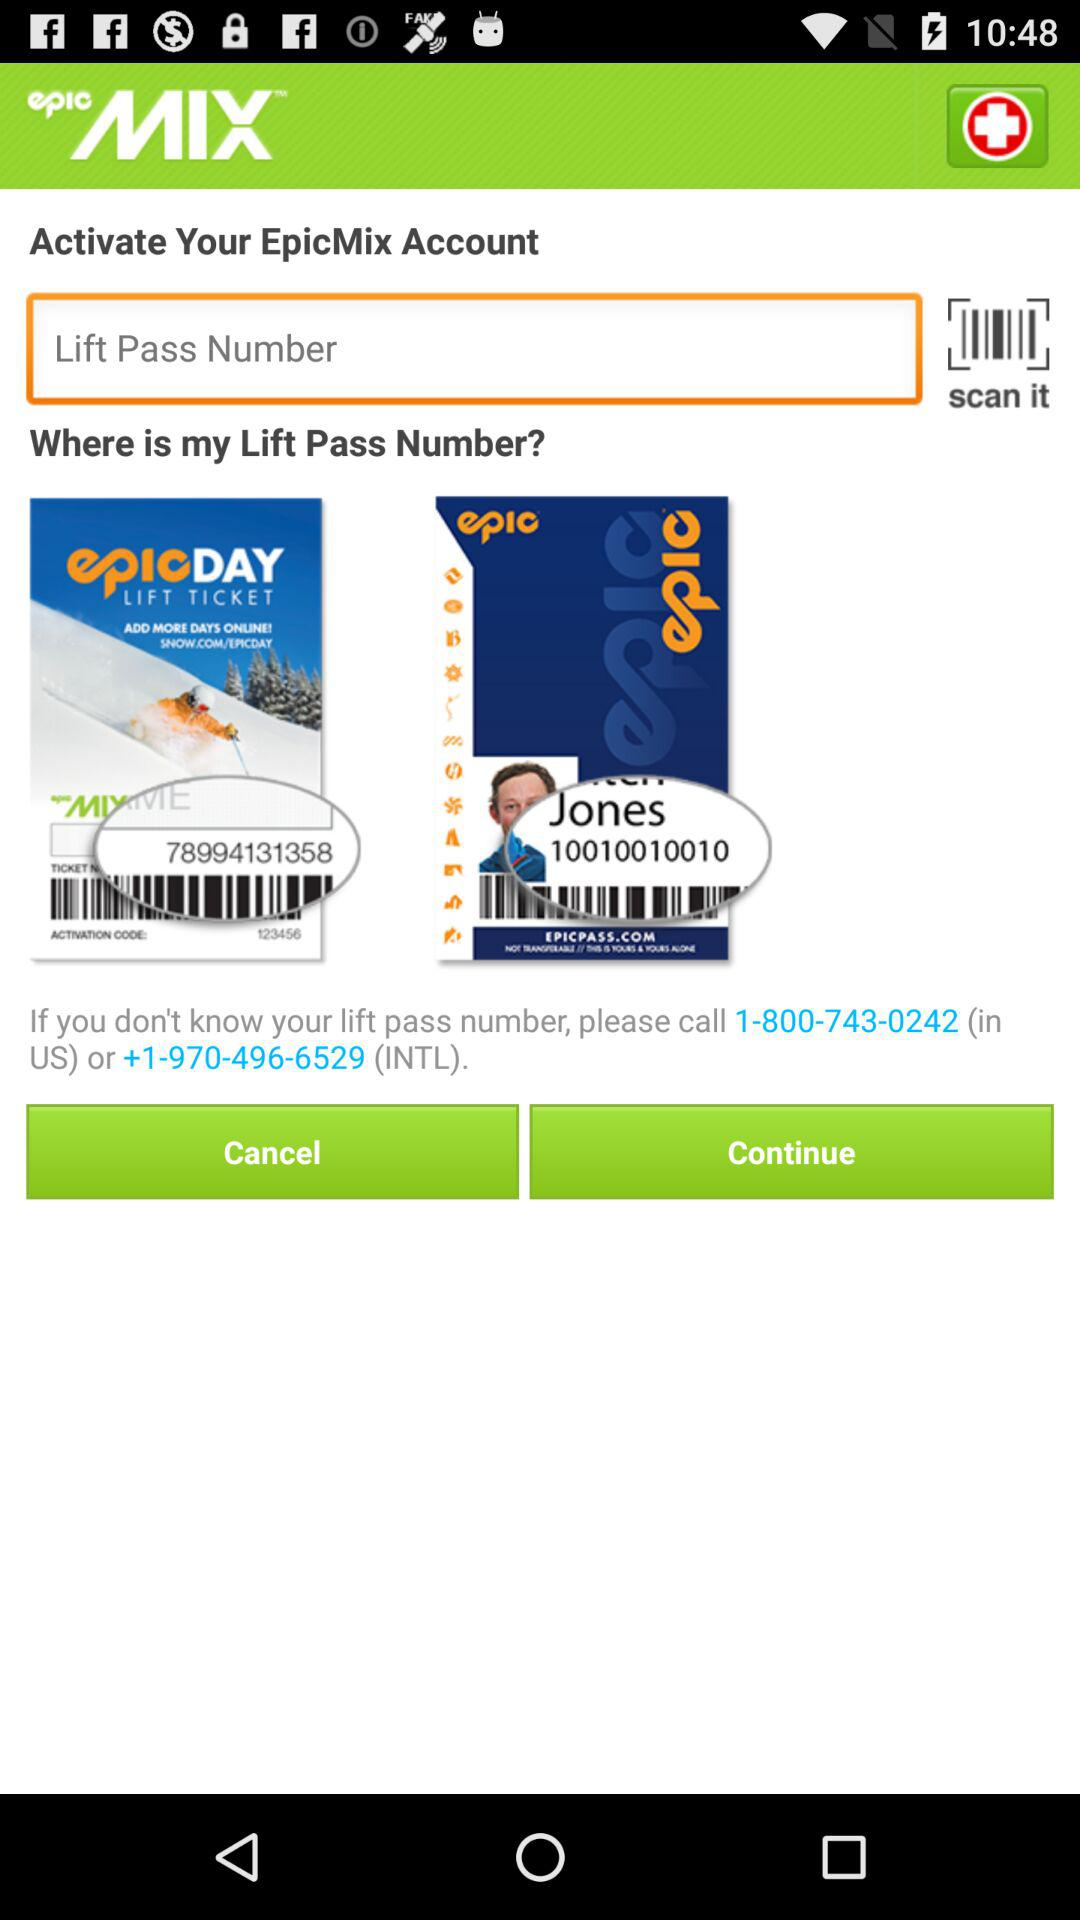What is the name of the application? The name of the application is "epicMIX". 